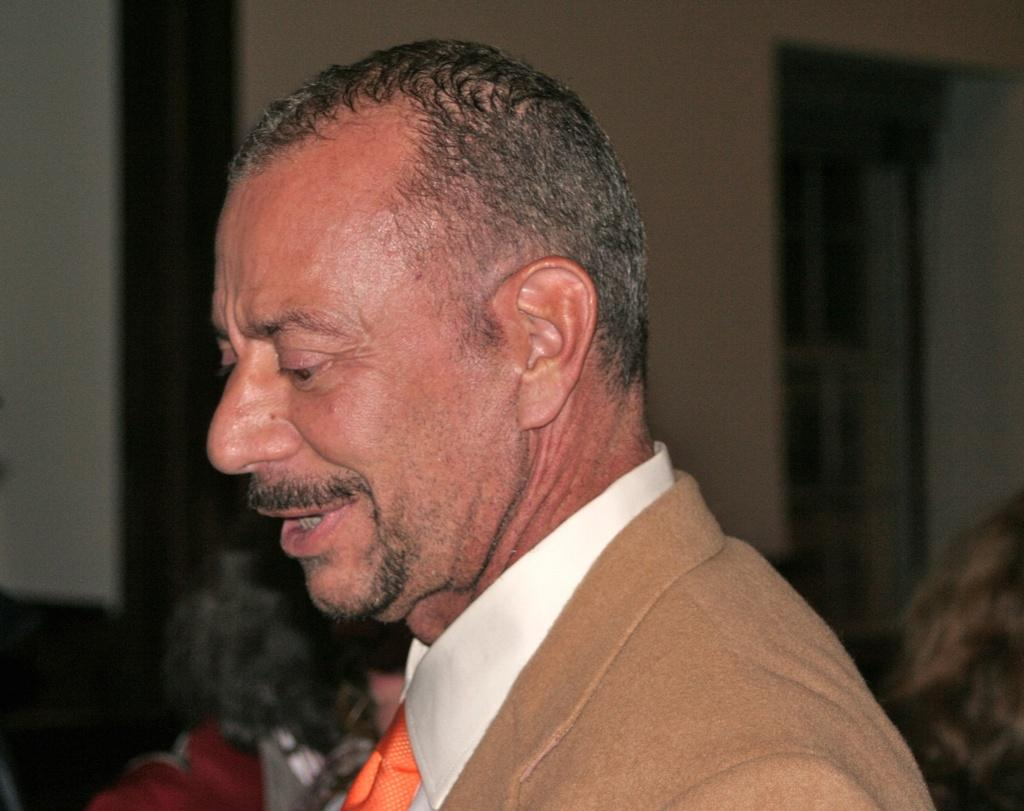Who is the main subject in the image? There is a man in the image. What can be observed about the background of the image? The background of the image is blurred. What channel: What channel is the man watching in the image? There is no information about a television or channel in the image. afternoon: What time of day is it in the image? The time of day or time of day is not mentioned or indicated in the image. patch: What type of patch is visible on the man's clothing in the image? There is no mention of a patch on the man's clothing in the provided facts. 